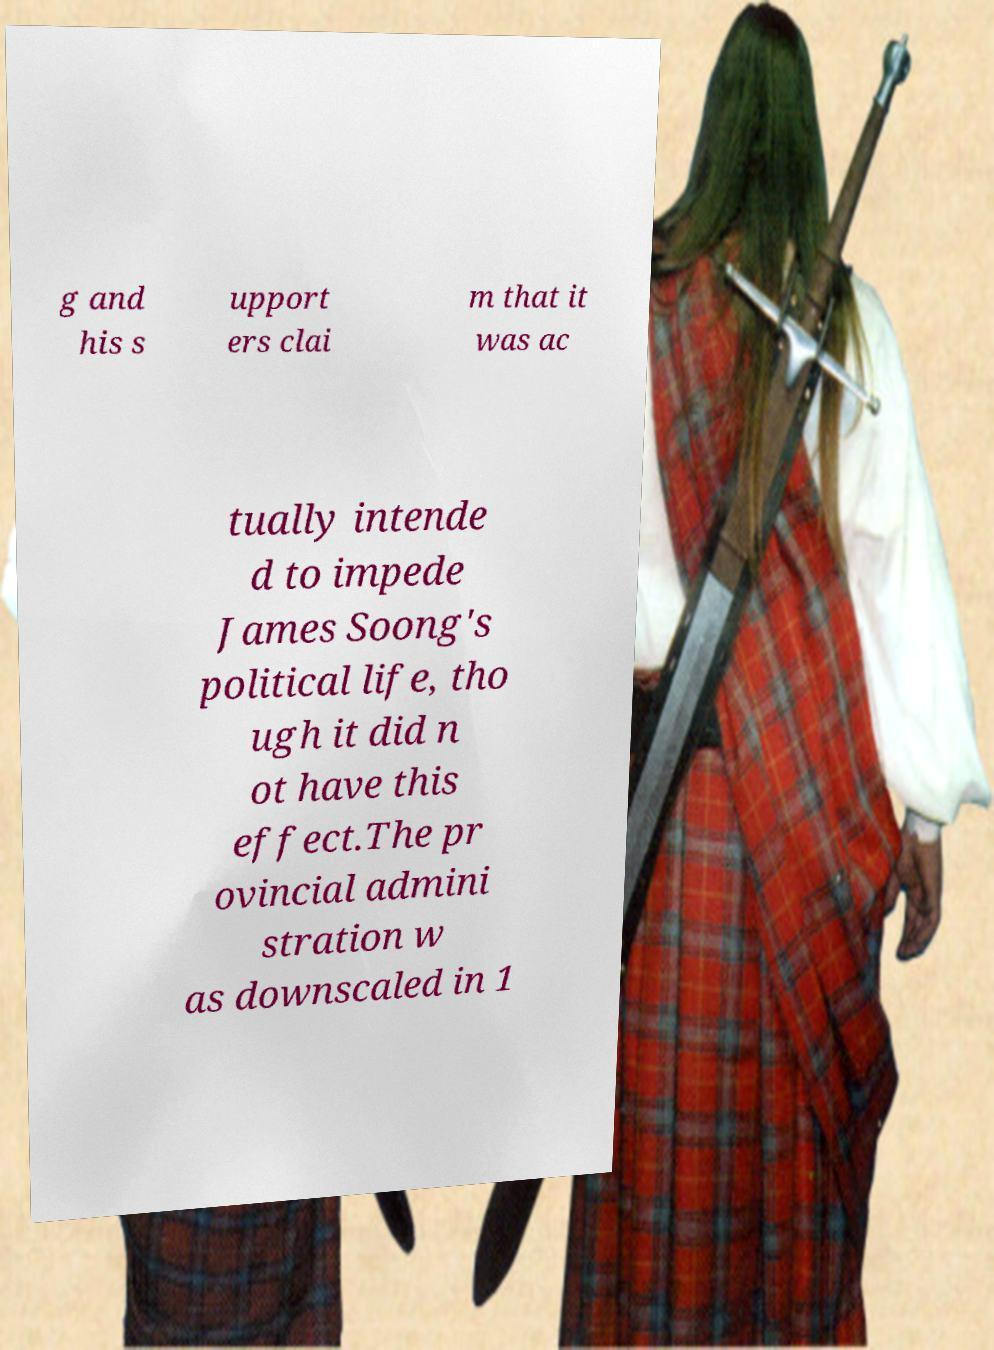Can you read and provide the text displayed in the image?This photo seems to have some interesting text. Can you extract and type it out for me? g and his s upport ers clai m that it was ac tually intende d to impede James Soong's political life, tho ugh it did n ot have this effect.The pr ovincial admini stration w as downscaled in 1 